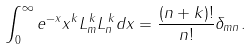Convert formula to latex. <formula><loc_0><loc_0><loc_500><loc_500>\int ^ { \infty } _ { 0 } e ^ { - x } x ^ { k } L _ { m } ^ { \, k } L _ { n } ^ { \, k } d x = \frac { ( n + k ) ! } { n ! } \delta _ { m n } .</formula> 